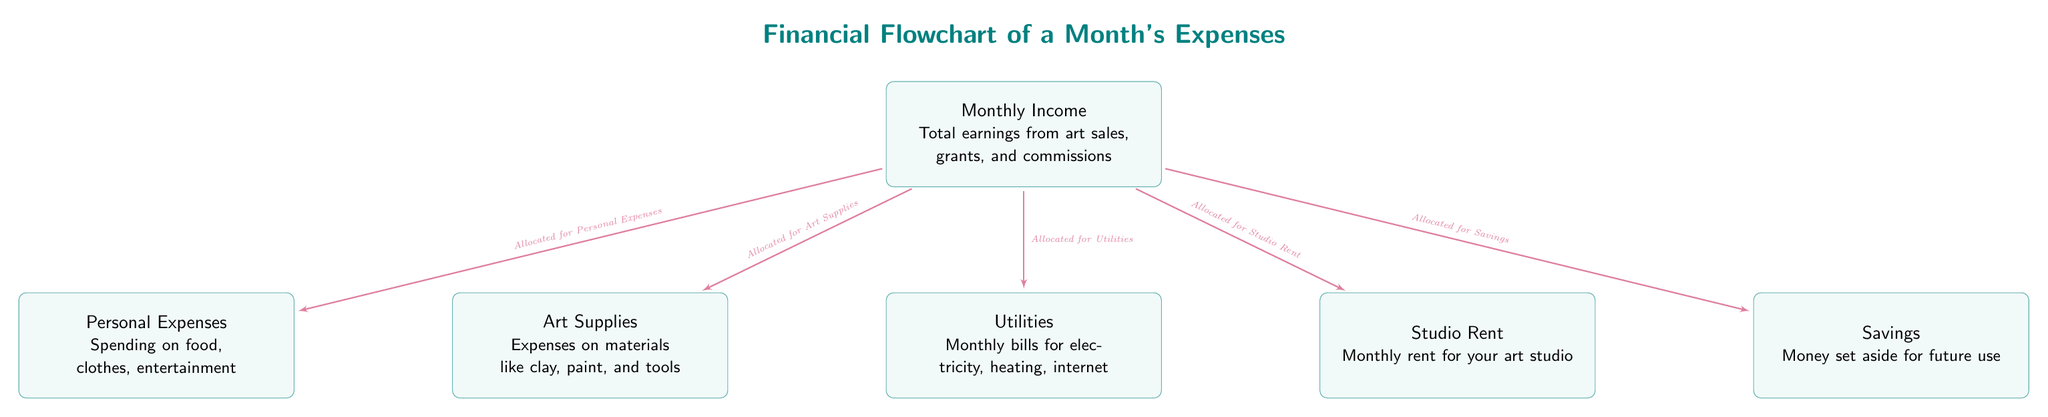What are the main categories of expenses outlined in the diagram? The diagram shows the main expenses as Art Supplies, Utilities, Studio Rent, and Personal Expenses. These categories are listed as nodes below the Monthly Income node.
Answer: Art Supplies, Utilities, Studio Rent, Personal Expenses How many nodes are there in total in the diagram? The diagram contains six nodes: one for Monthly Income and five for expenses (Art Supplies, Utilities, Studio Rent, Personal Expenses, and Savings). Therefore, 1 (Monthly Income) + 5 (expenses) equals 6 nodes in total.
Answer: 6 What is allocated for Savings according to the diagram? The diagram indicates that a portion of the Monthly Income is allocated for Savings. This is shown by the directed line from the Monthly Income node to the Savings node labeled "Allocated for Savings."
Answer: Allocated for Savings Which expenses are directly associated with Monthly Income? The nodes directly connected to Monthly Income are Art Supplies, Utilities, Studio Rent, Personal Expenses, and Savings. Each expense node has a line connecting it to the income node, signifying direct allocation from Monthly Income.
Answer: Art Supplies, Utilities, Studio Rent, Personal Expenses, Savings What is the label associated with the connection to Art Supplies? The direction from Monthly Income to Art Supplies is labeled "Allocated for Art Supplies." This label appears above the line that connects these two nodes, indicating the allocation purpose.
Answer: Allocated for Art Supplies What type of diagram is this? The diagram depicts a flowchart specifically designed to illustrate financial allocations of a month's expenses. It uses nodes to represent income and expenses, with arrows showing the flow of money.
Answer: Flowchart 